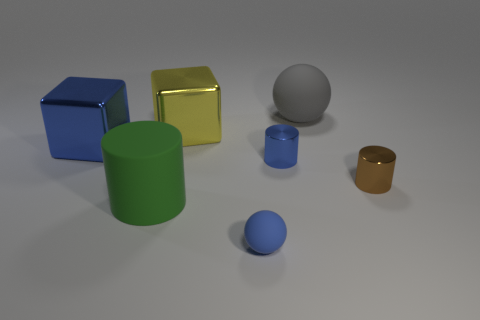Add 1 small shiny things. How many objects exist? 8 Subtract all tiny blue cylinders. How many cylinders are left? 2 Subtract all blocks. How many objects are left? 5 Subtract all brown cylinders. How many cylinders are left? 2 Subtract all blue cubes. Subtract all cyan cylinders. How many cubes are left? 1 Subtract all tiny blue matte blocks. Subtract all gray matte things. How many objects are left? 6 Add 1 tiny brown things. How many tiny brown things are left? 2 Add 1 large green objects. How many large green objects exist? 2 Subtract 1 yellow blocks. How many objects are left? 6 Subtract 2 cylinders. How many cylinders are left? 1 